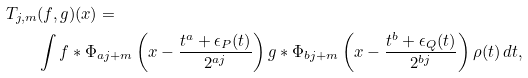<formula> <loc_0><loc_0><loc_500><loc_500>T _ { j , m } & ( f , g ) ( x ) = \\ & \int f * \Phi _ { a j + m } \left ( x - \frac { t ^ { a } + \epsilon _ { P } ( t ) } { 2 ^ { a j } } \right ) g * \Phi _ { b j + m } \left ( x - \frac { t ^ { b } + \epsilon _ { Q } ( t ) } { 2 ^ { b j } } \right ) \rho ( t ) \, d t ,</formula> 